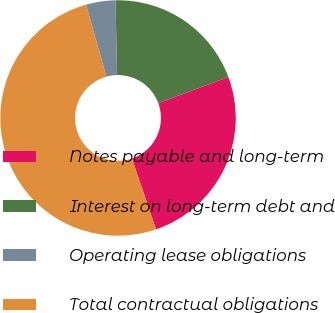Convert chart to OTSL. <chart><loc_0><loc_0><loc_500><loc_500><pie_chart><fcel>Notes payable and long-term<fcel>Interest on long-term debt and<fcel>Operating lease obligations<fcel>Total contractual obligations<nl><fcel>25.42%<fcel>19.69%<fcel>4.04%<fcel>50.85%<nl></chart> 